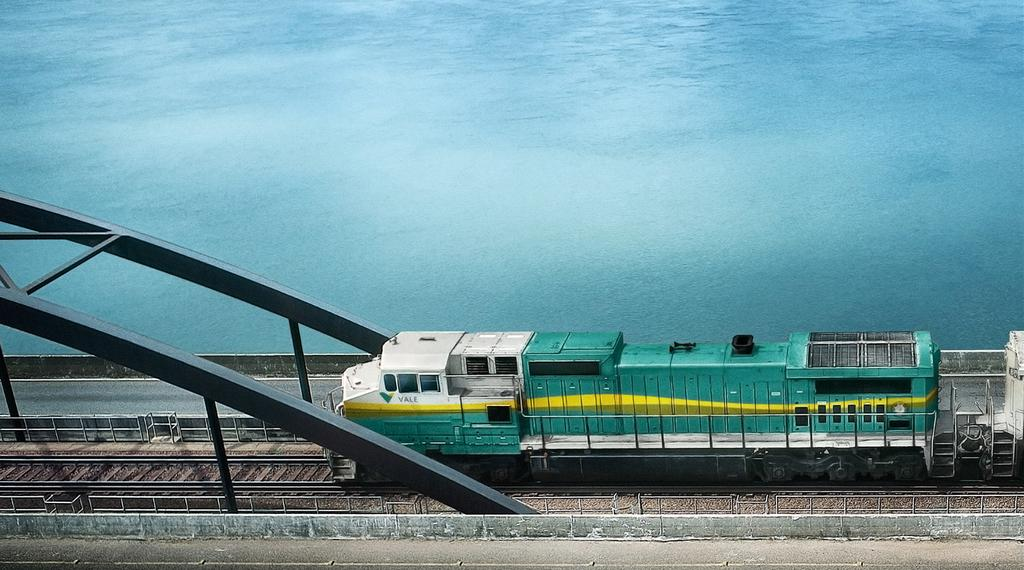What is the main subject of the image? There is a train in the image. Where is the train located? The train is on a railway track. What else can be seen in the image besides the train? There are poles and a fence visible in the image. What natural element is present in the image? There is water visible in the image. What type of building can be seen in the image? There is no building present in the image; it features a train on a railway track, poles, a fence, and water. 